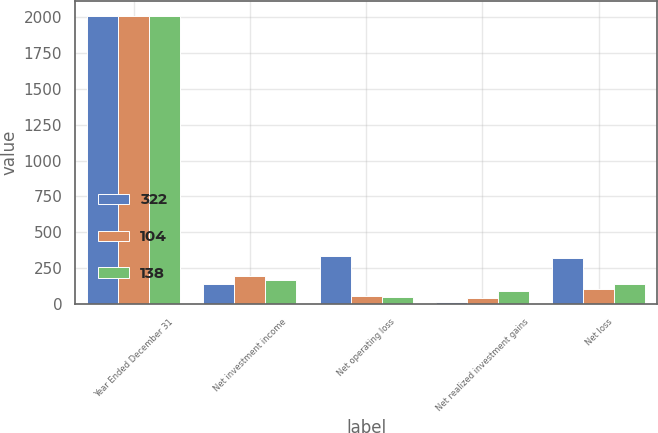Convert chart to OTSL. <chart><loc_0><loc_0><loc_500><loc_500><stacked_bar_chart><ecel><fcel>Year Ended December 31<fcel>Net investment income<fcel>Net operating loss<fcel>Net realized investment gains<fcel>Net loss<nl><fcel>322<fcel>2010<fcel>137<fcel>334<fcel>12<fcel>322<nl><fcel>104<fcel>2009<fcel>195<fcel>59<fcel>45<fcel>104<nl><fcel>138<fcel>2008<fcel>169<fcel>50<fcel>88<fcel>138<nl></chart> 